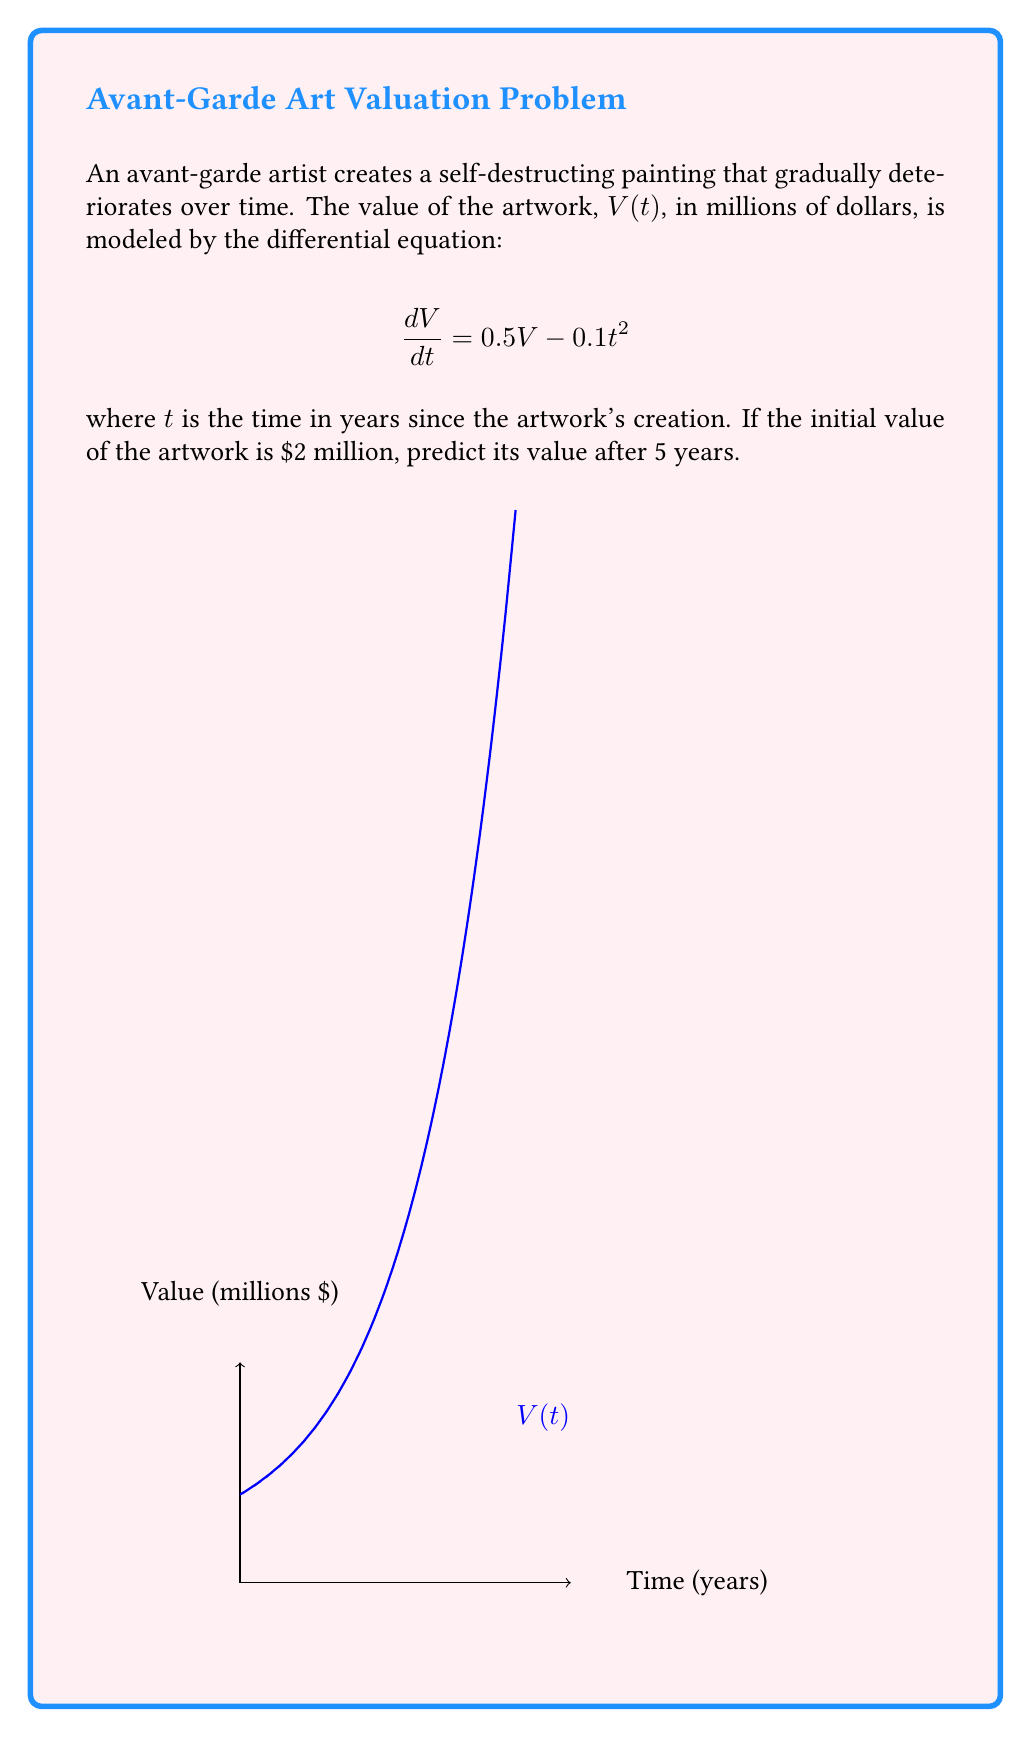Can you solve this math problem? To solve this first-order linear differential equation:

1) The general solution for this type of equation is:
   $$V(t) = e^{\int 0.5 dt} \left(C - \int 0.1t^2 e^{-\int 0.5 dt} dt\right)$$

2) Solving the integrals:
   $$V(t) = e^{0.5t} \left(C - \int 0.1t^2 e^{-0.5t} dt\right)$$

3) Integrating by parts:
   $$V(t) = e^{0.5t} \left(C - 0.1\left(-\frac{4t^2}{e^{0.5t}} - \frac{16t}{e^{0.5t}} - \frac{32}{e^{0.5t}}\right) + D\right)$$

4) Simplifying:
   $$V(t) = e^{0.5t} \left(C + 0.4t^2 + 1.6t + 3.2\right) + De^{0.5t}$$
   $$V(t) = e^{0.5t} \left(K + 0.4t^2 + 1.6t + 3.2\right)$$

5) Using the initial condition V(0) = 2:
   $$2 = K + 3.2$$
   $$K = -1.2$$

6) Therefore, the particular solution is:
   $$V(t) = e^{0.5t} \left(-1.2 + 0.4t^2 + 1.6t + 3.2\right)$$

7) Evaluating at t = 5:
   $$V(5) = e^{2.5} \left(-1.2 + 0.4(25) + 1.6(5) + 3.2\right)$$
   $$V(5) = e^{2.5} (14)$$
   $$V(5) \approx 170.43$$
Answer: $170.43 million 